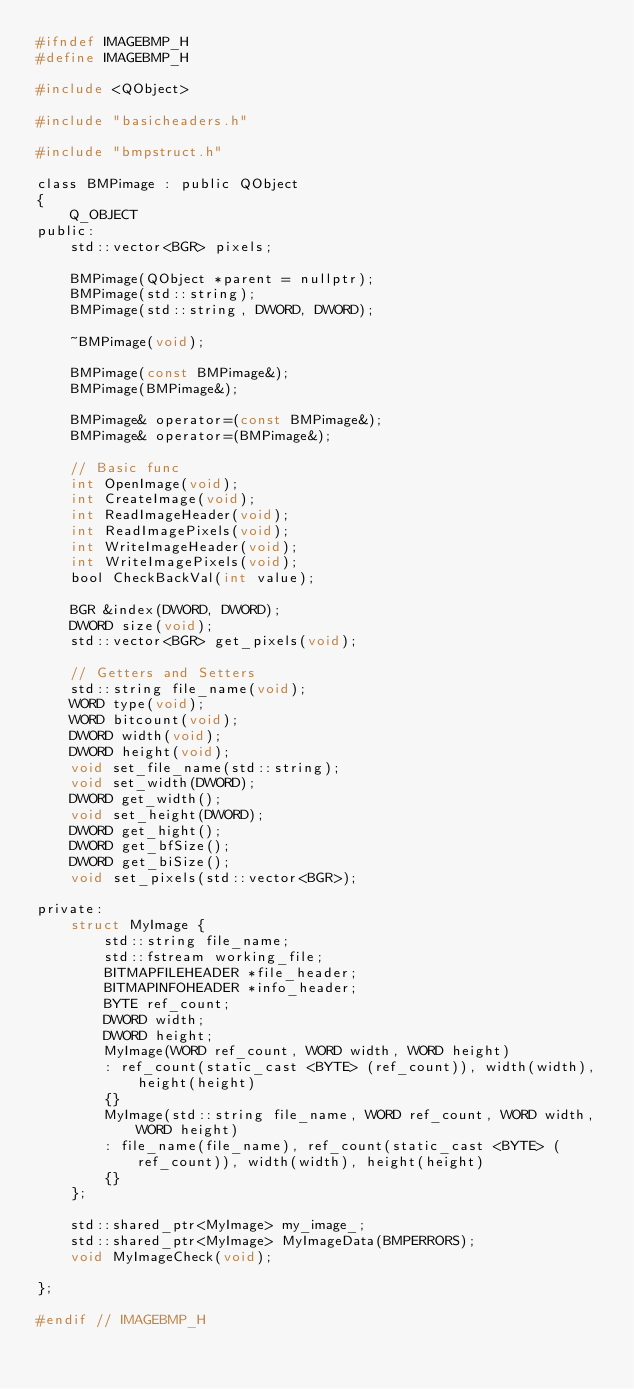<code> <loc_0><loc_0><loc_500><loc_500><_C_>#ifndef IMAGEBMP_H
#define IMAGEBMP_H

#include <QObject>

#include "basicheaders.h"

#include "bmpstruct.h"

class BMPimage : public QObject
{
    Q_OBJECT
public:
    std::vector<BGR> pixels;

    BMPimage(QObject *parent = nullptr);
    BMPimage(std::string);
    BMPimage(std::string, DWORD, DWORD);

    ~BMPimage(void);

    BMPimage(const BMPimage&);
    BMPimage(BMPimage&);

    BMPimage& operator=(const BMPimage&);
    BMPimage& operator=(BMPimage&);

    // Basic func
    int OpenImage(void);
    int CreateImage(void);
    int ReadImageHeader(void);
    int ReadImagePixels(void);
    int WriteImageHeader(void);
    int WriteImagePixels(void);
    bool CheckBackVal(int value);

    BGR &index(DWORD, DWORD);
    DWORD size(void);
    std::vector<BGR> get_pixels(void);

    // Getters and Setters
    std::string file_name(void);
    WORD type(void);
    WORD bitcount(void);
    DWORD width(void);
    DWORD height(void);
    void set_file_name(std::string);
    void set_width(DWORD);
    DWORD get_width();
    void set_height(DWORD);
    DWORD get_hight();
    DWORD get_bfSize();
    DWORD get_biSize();
    void set_pixels(std::vector<BGR>);

private:
    struct MyImage {
        std::string file_name;
        std::fstream working_file;
        BITMAPFILEHEADER *file_header;
        BITMAPINFOHEADER *info_header;
        BYTE ref_count;
        DWORD width;
        DWORD height;
        MyImage(WORD ref_count, WORD width, WORD height)
        : ref_count(static_cast <BYTE> (ref_count)), width(width), height(height)
        {}
        MyImage(std::string file_name, WORD ref_count, WORD width, WORD height)
        : file_name(file_name), ref_count(static_cast <BYTE> (ref_count)), width(width), height(height)
        {}
    };

    std::shared_ptr<MyImage> my_image_;
    std::shared_ptr<MyImage> MyImageData(BMPERRORS);
    void MyImageCheck(void);

};

#endif // IMAGEBMP_H
</code> 